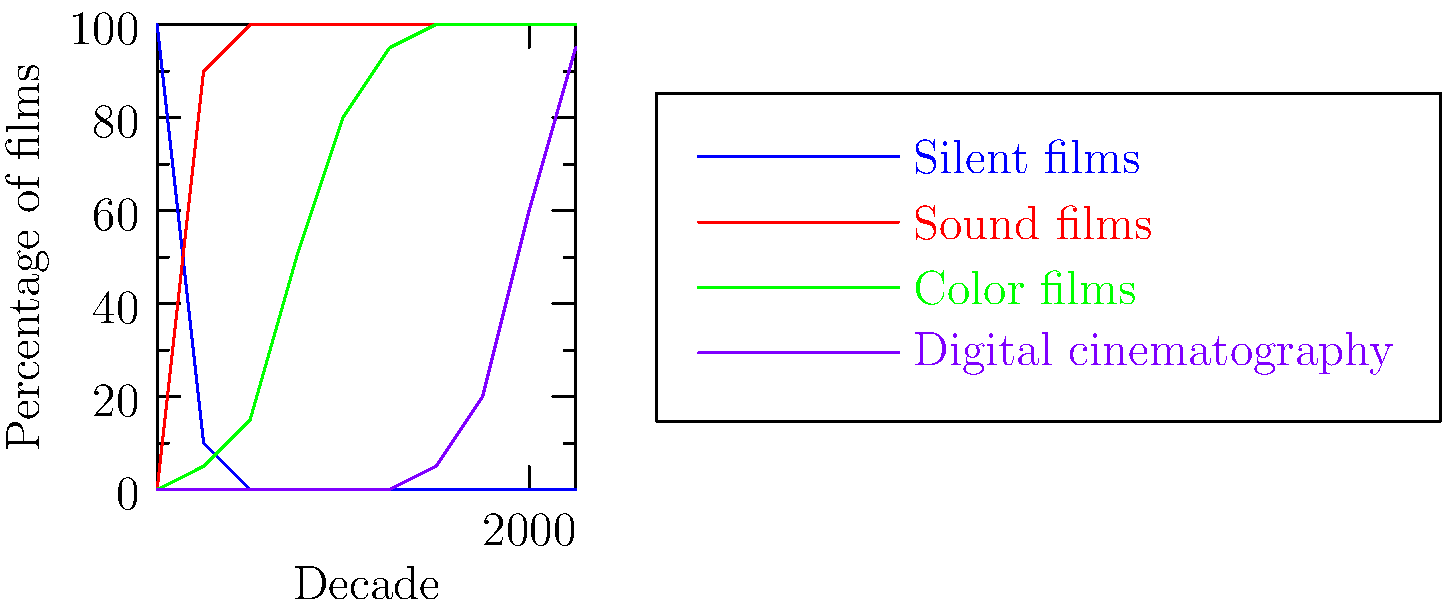Based on the graph, which cinematographic technology showed the most rapid adoption between the 1940s and 1960s, significantly impacting the visual aesthetics of films during this period? To answer this question, we need to analyze the trends for each technology shown in the graph between the 1940s and 1960s:

1. Silent films: Already at 0% by 1940, no change.
2. Sound films: Already at 100% by 1940, no change.
3. Digital cinematography: Not yet introduced in this period.
4. Color films: This is the technology that shows the most significant change.

Let's examine the color film trend:
- 1940: approximately 15% of films
- 1950: increased to about 50% of films
- 1960: reached around 80% of films

The adoption of color film technology increased from 15% to 80% over these two decades, representing the most rapid and significant change among the technologies shown. This shift from predominantly black-and-white to color films would have had a profound impact on the visual aesthetics of cinema during this period, allowing filmmakers to use color as an expressive tool in storytelling and cinematography.
Answer: Color film technology 